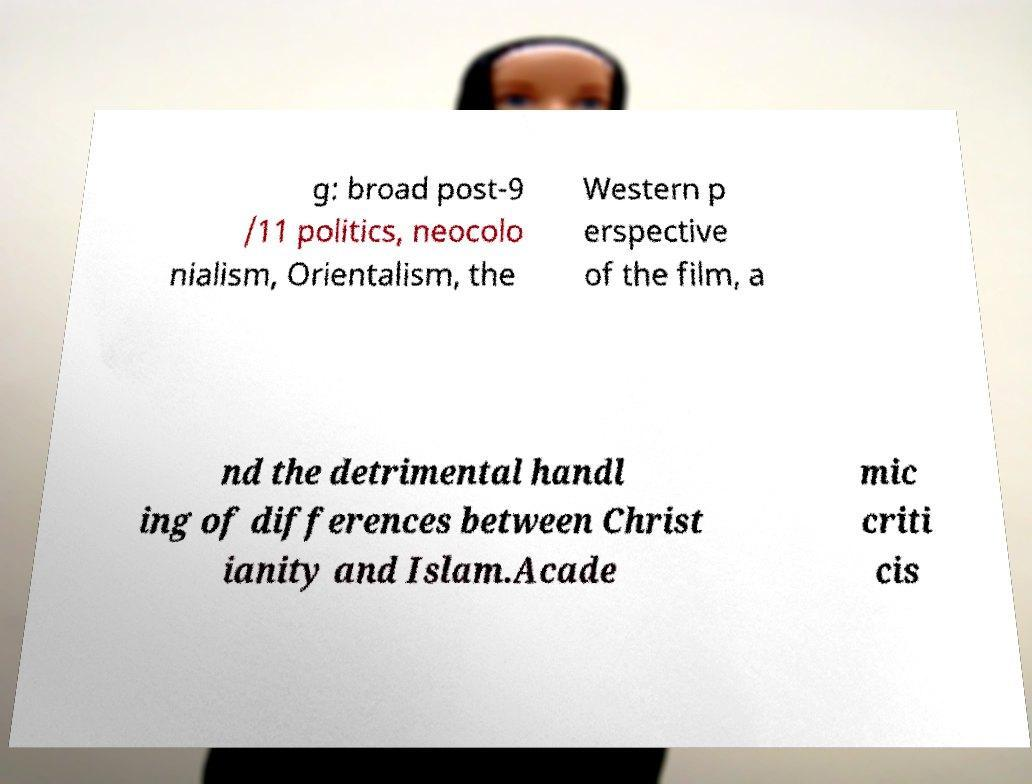I need the written content from this picture converted into text. Can you do that? g: broad post-9 /11 politics, neocolo nialism, Orientalism, the Western p erspective of the film, a nd the detrimental handl ing of differences between Christ ianity and Islam.Acade mic criti cis 